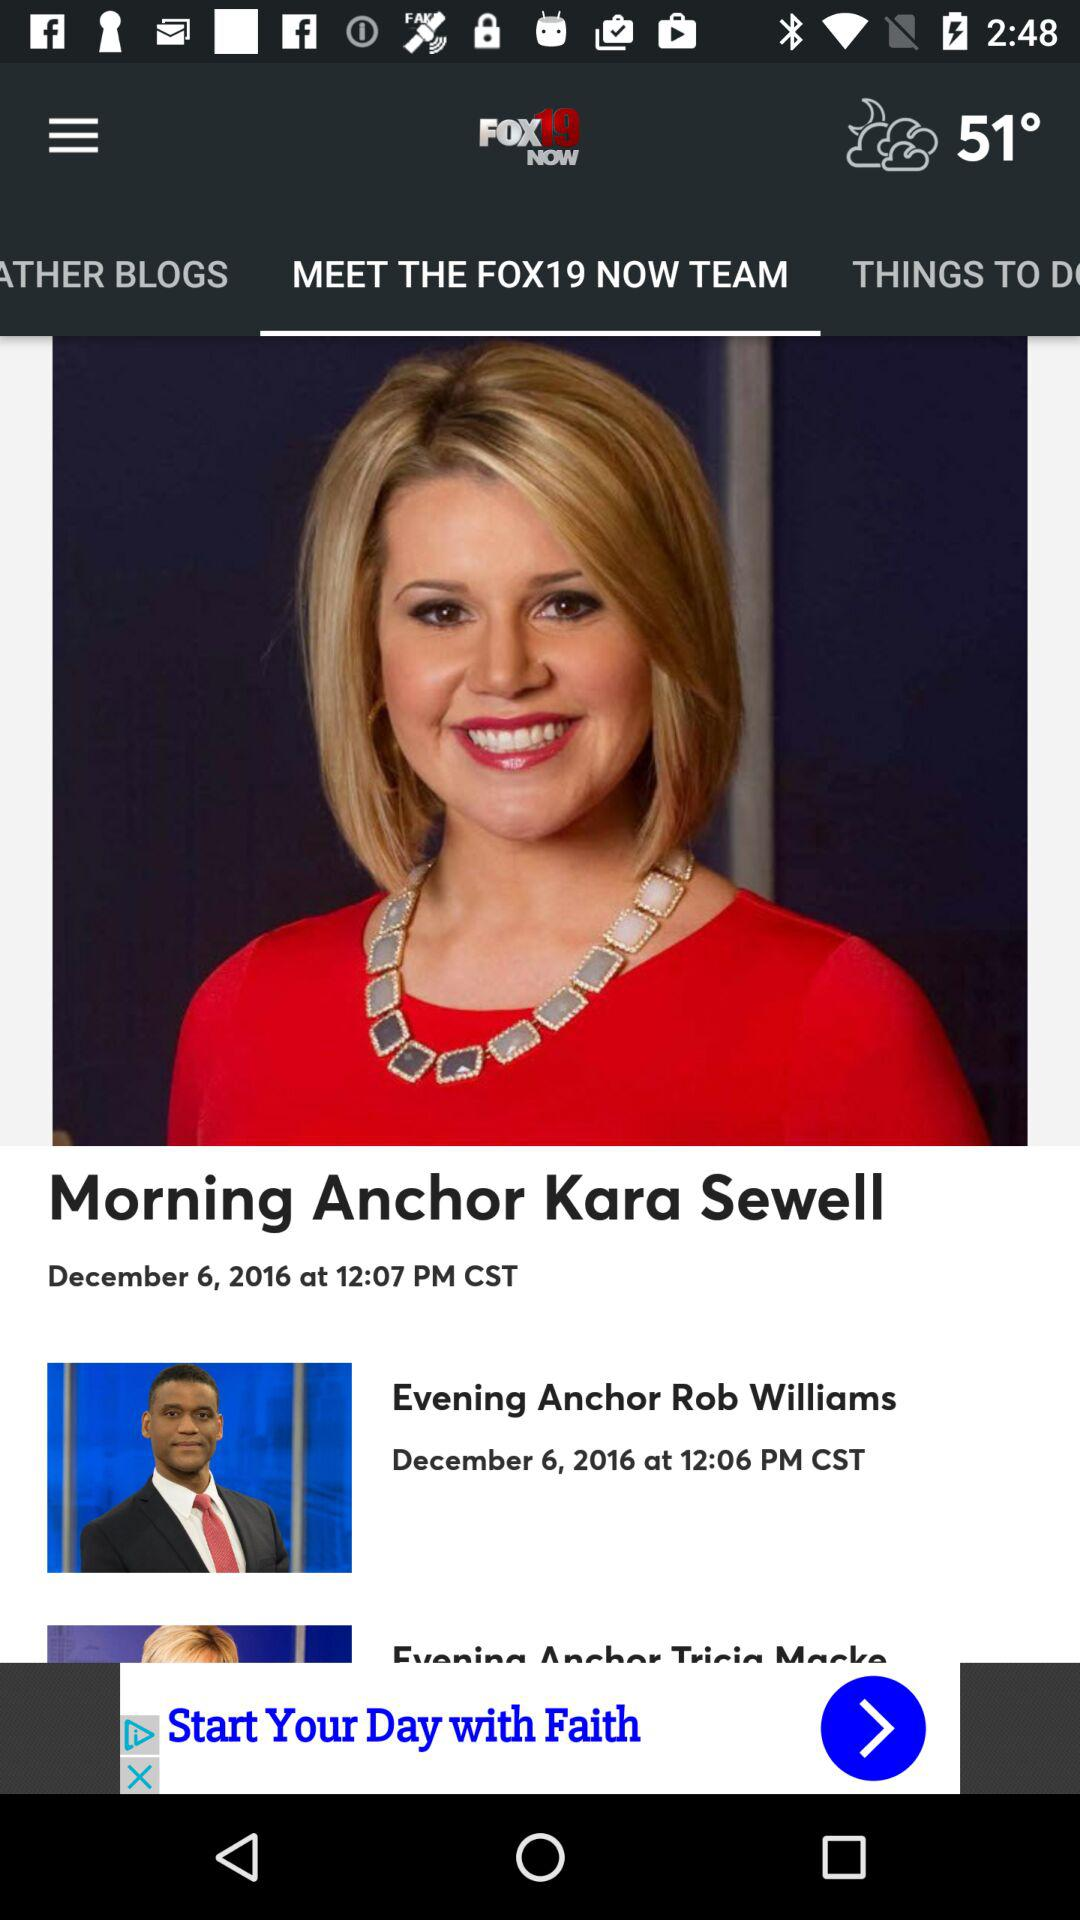What is the selected tab? The selected tab is "MEET THE FOX19 NOW TEAM". 